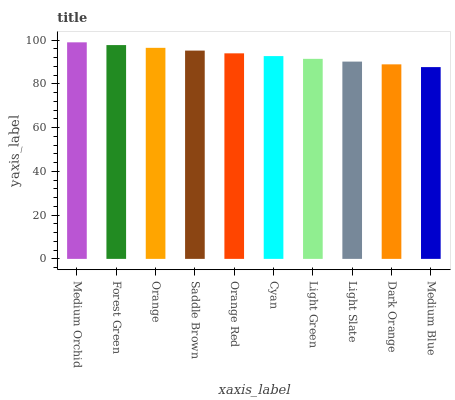Is Medium Blue the minimum?
Answer yes or no. Yes. Is Medium Orchid the maximum?
Answer yes or no. Yes. Is Forest Green the minimum?
Answer yes or no. No. Is Forest Green the maximum?
Answer yes or no. No. Is Medium Orchid greater than Forest Green?
Answer yes or no. Yes. Is Forest Green less than Medium Orchid?
Answer yes or no. Yes. Is Forest Green greater than Medium Orchid?
Answer yes or no. No. Is Medium Orchid less than Forest Green?
Answer yes or no. No. Is Orange Red the high median?
Answer yes or no. Yes. Is Cyan the low median?
Answer yes or no. Yes. Is Saddle Brown the high median?
Answer yes or no. No. Is Orange Red the low median?
Answer yes or no. No. 